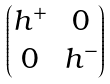<formula> <loc_0><loc_0><loc_500><loc_500>\begin{pmatrix} h ^ { + } & 0 \\ 0 & h ^ { - } \end{pmatrix}</formula> 